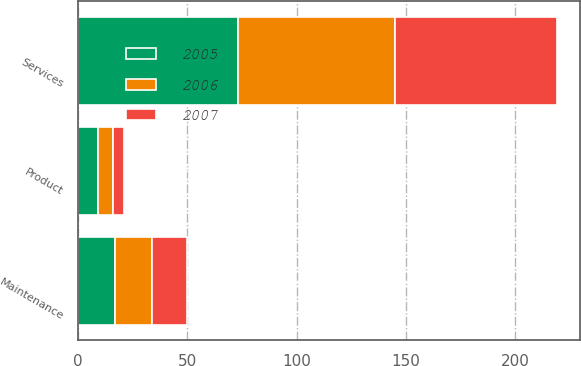Convert chart to OTSL. <chart><loc_0><loc_0><loc_500><loc_500><stacked_bar_chart><ecel><fcel>Product<fcel>Services<fcel>Maintenance<nl><fcel>2007<fcel>5<fcel>74<fcel>16<nl><fcel>2006<fcel>7<fcel>72<fcel>17<nl><fcel>2005<fcel>9<fcel>73<fcel>17<nl></chart> 